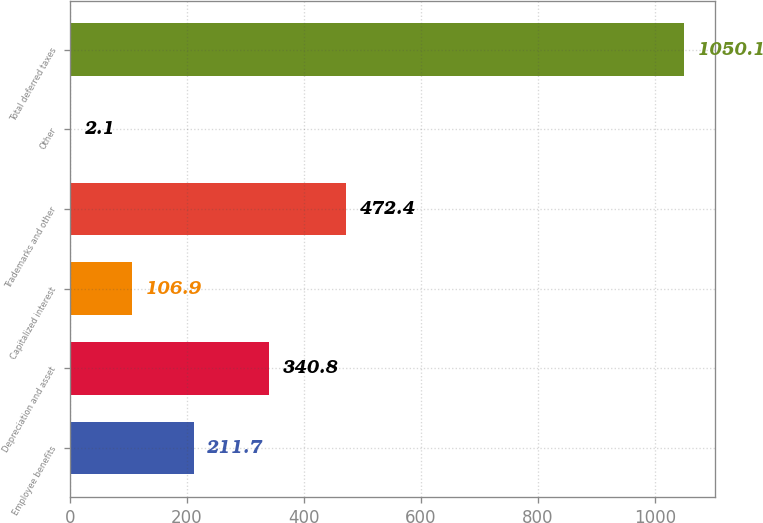Convert chart to OTSL. <chart><loc_0><loc_0><loc_500><loc_500><bar_chart><fcel>Employee benefits<fcel>Depreciation and asset<fcel>Capitalized interest<fcel>Trademarks and other<fcel>Other<fcel>Total deferred taxes<nl><fcel>211.7<fcel>340.8<fcel>106.9<fcel>472.4<fcel>2.1<fcel>1050.1<nl></chart> 